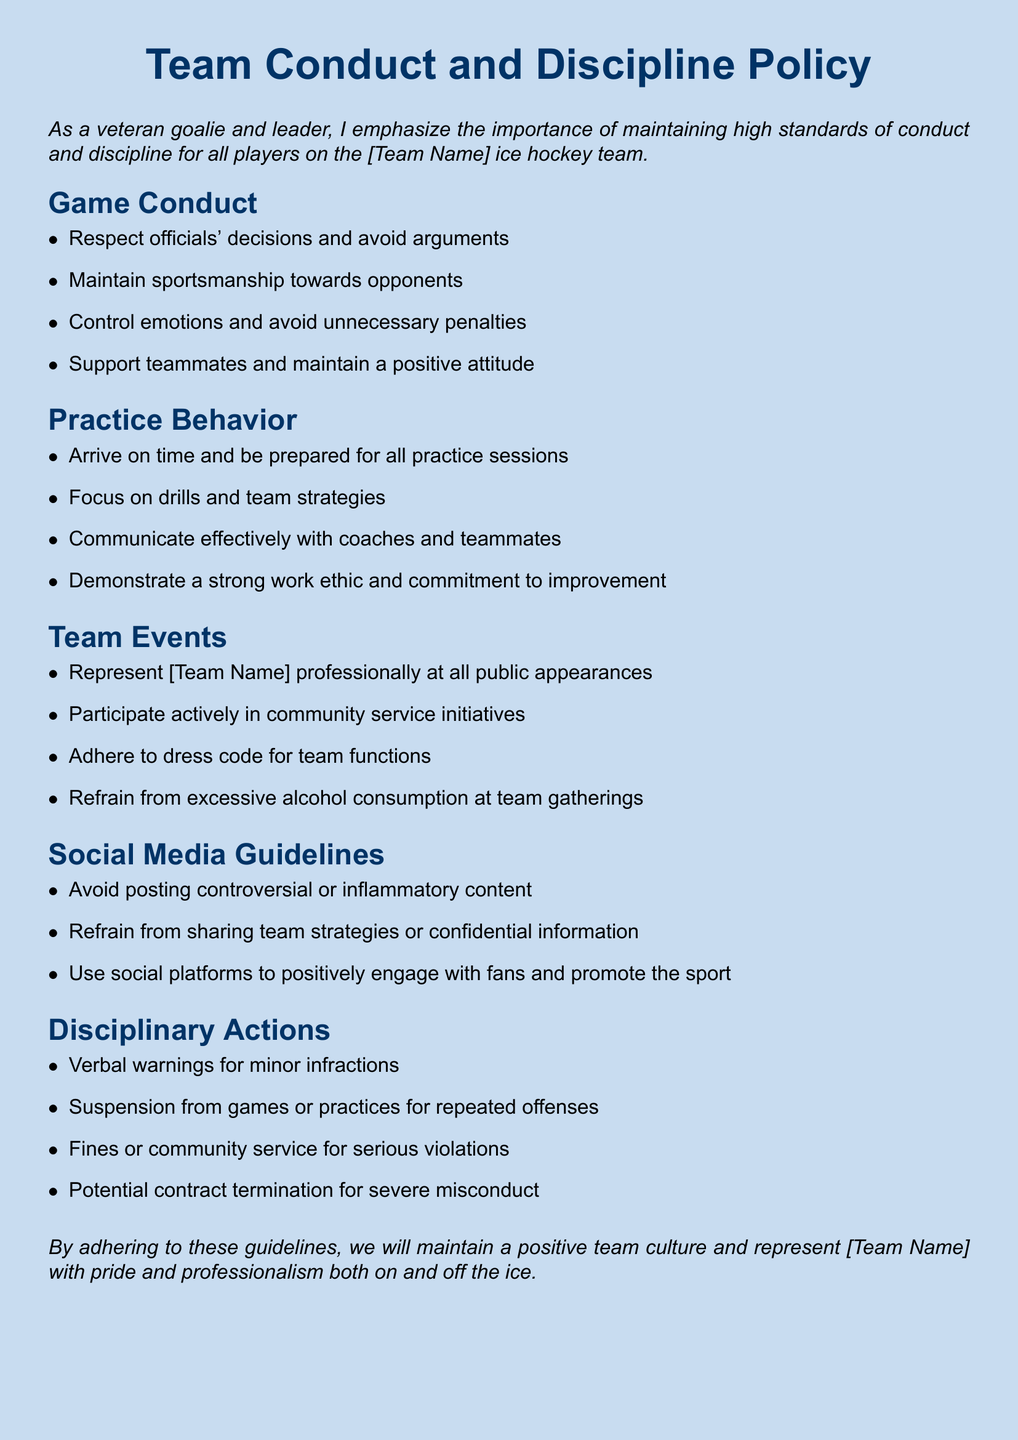What is the title of the document? The title of the document is prominently displayed at the top as "Team Conduct and Discipline Policy".
Answer: Team Conduct and Discipline Policy What should players maintain during games? The document specifies that players should maintain sportsmanship towards opponents during games.
Answer: Sportsmanship What is one expectation for practice behavior? The document states that players should arrive on time and be prepared for all practice sessions.
Answer: Arrive on time What is a guideline for social media use? The document indicates that players should avoid posting controversial or inflammatory content on social media.
Answer: Avoid posting controversial content What can happen for repeated infractions? The disciplinary actions section mentions that players may face suspension from games or practices for repeated offenses.
Answer: Suspension How should players represent the team at public appearances? The document specifies that players should represent the team professionally at all public appearances.
Answer: Professionally What is a consequence for serious violations? Serious violations can lead to fines or community service, as outlined in the document's disciplinary actions.
Answer: Fines or community service What is required for team events regarding dress? The document states that players must adhere to a dress code for team functions.
Answer: Dress code What is emphasized as important for team culture? The document highlights maintaining a positive team culture as important for representing the team.
Answer: Positive team culture 